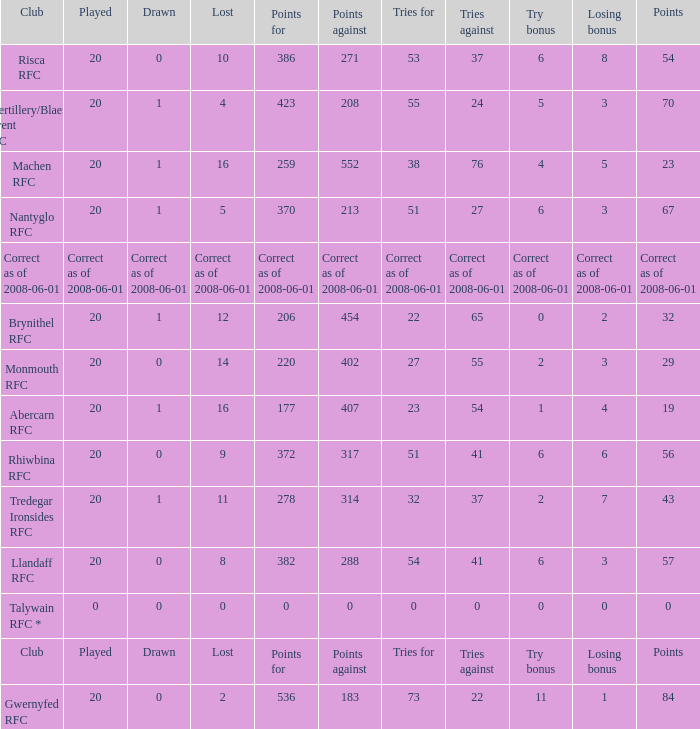If the points were 0, what was the losing bonus? 0.0. 